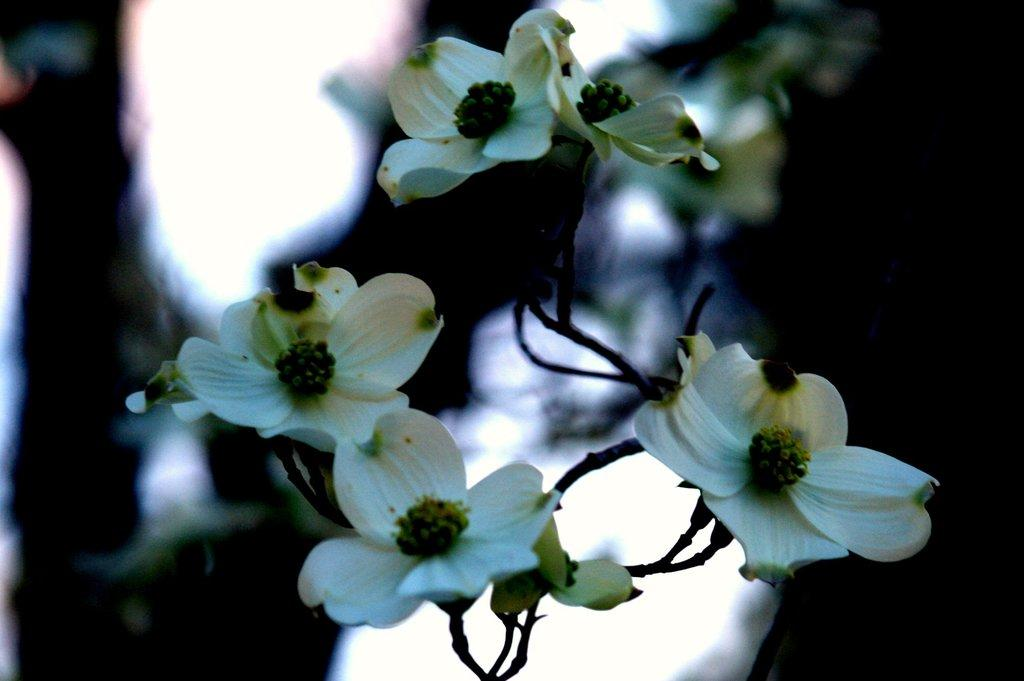What type of plant is visible in the image? The image features a plant with flowers on its stem. Can you describe the flowers on the plant? The flowers are visible on the stem of the plant. What color is the gold twig in the image? There is no gold twig present in the image; the image features a plant with flowers on its stem. 